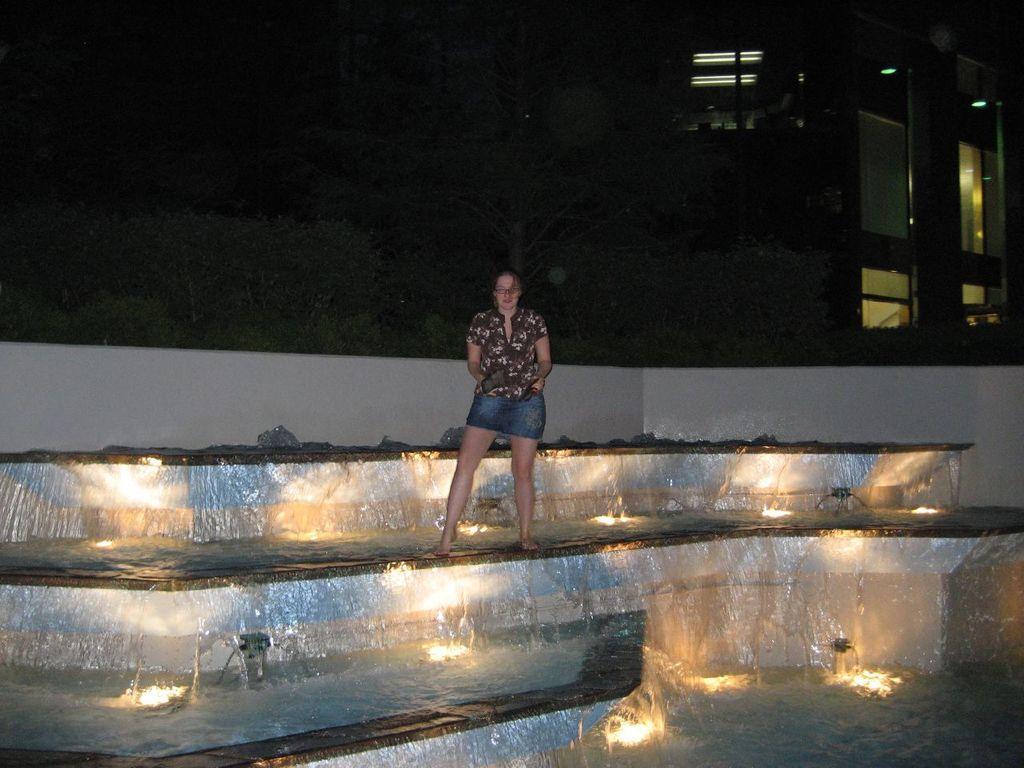Describe this image in one or two sentences. In this image I can see a person standing on the water and the person is wearing brown shirt and blue short and I can see few stairs and lights. Background I can see few buildings. 